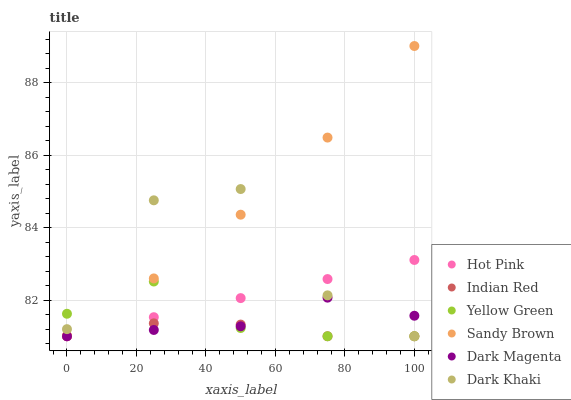Does Indian Red have the minimum area under the curve?
Answer yes or no. Yes. Does Sandy Brown have the maximum area under the curve?
Answer yes or no. Yes. Does Hot Pink have the minimum area under the curve?
Answer yes or no. No. Does Hot Pink have the maximum area under the curve?
Answer yes or no. No. Is Hot Pink the smoothest?
Answer yes or no. Yes. Is Dark Khaki the roughest?
Answer yes or no. Yes. Is Dark Khaki the smoothest?
Answer yes or no. No. Is Hot Pink the roughest?
Answer yes or no. No. Does Yellow Green have the lowest value?
Answer yes or no. Yes. Does Sandy Brown have the lowest value?
Answer yes or no. No. Does Sandy Brown have the highest value?
Answer yes or no. Yes. Does Hot Pink have the highest value?
Answer yes or no. No. Is Indian Red less than Sandy Brown?
Answer yes or no. Yes. Is Sandy Brown greater than Dark Magenta?
Answer yes or no. Yes. Does Yellow Green intersect Hot Pink?
Answer yes or no. Yes. Is Yellow Green less than Hot Pink?
Answer yes or no. No. Is Yellow Green greater than Hot Pink?
Answer yes or no. No. Does Indian Red intersect Sandy Brown?
Answer yes or no. No. 